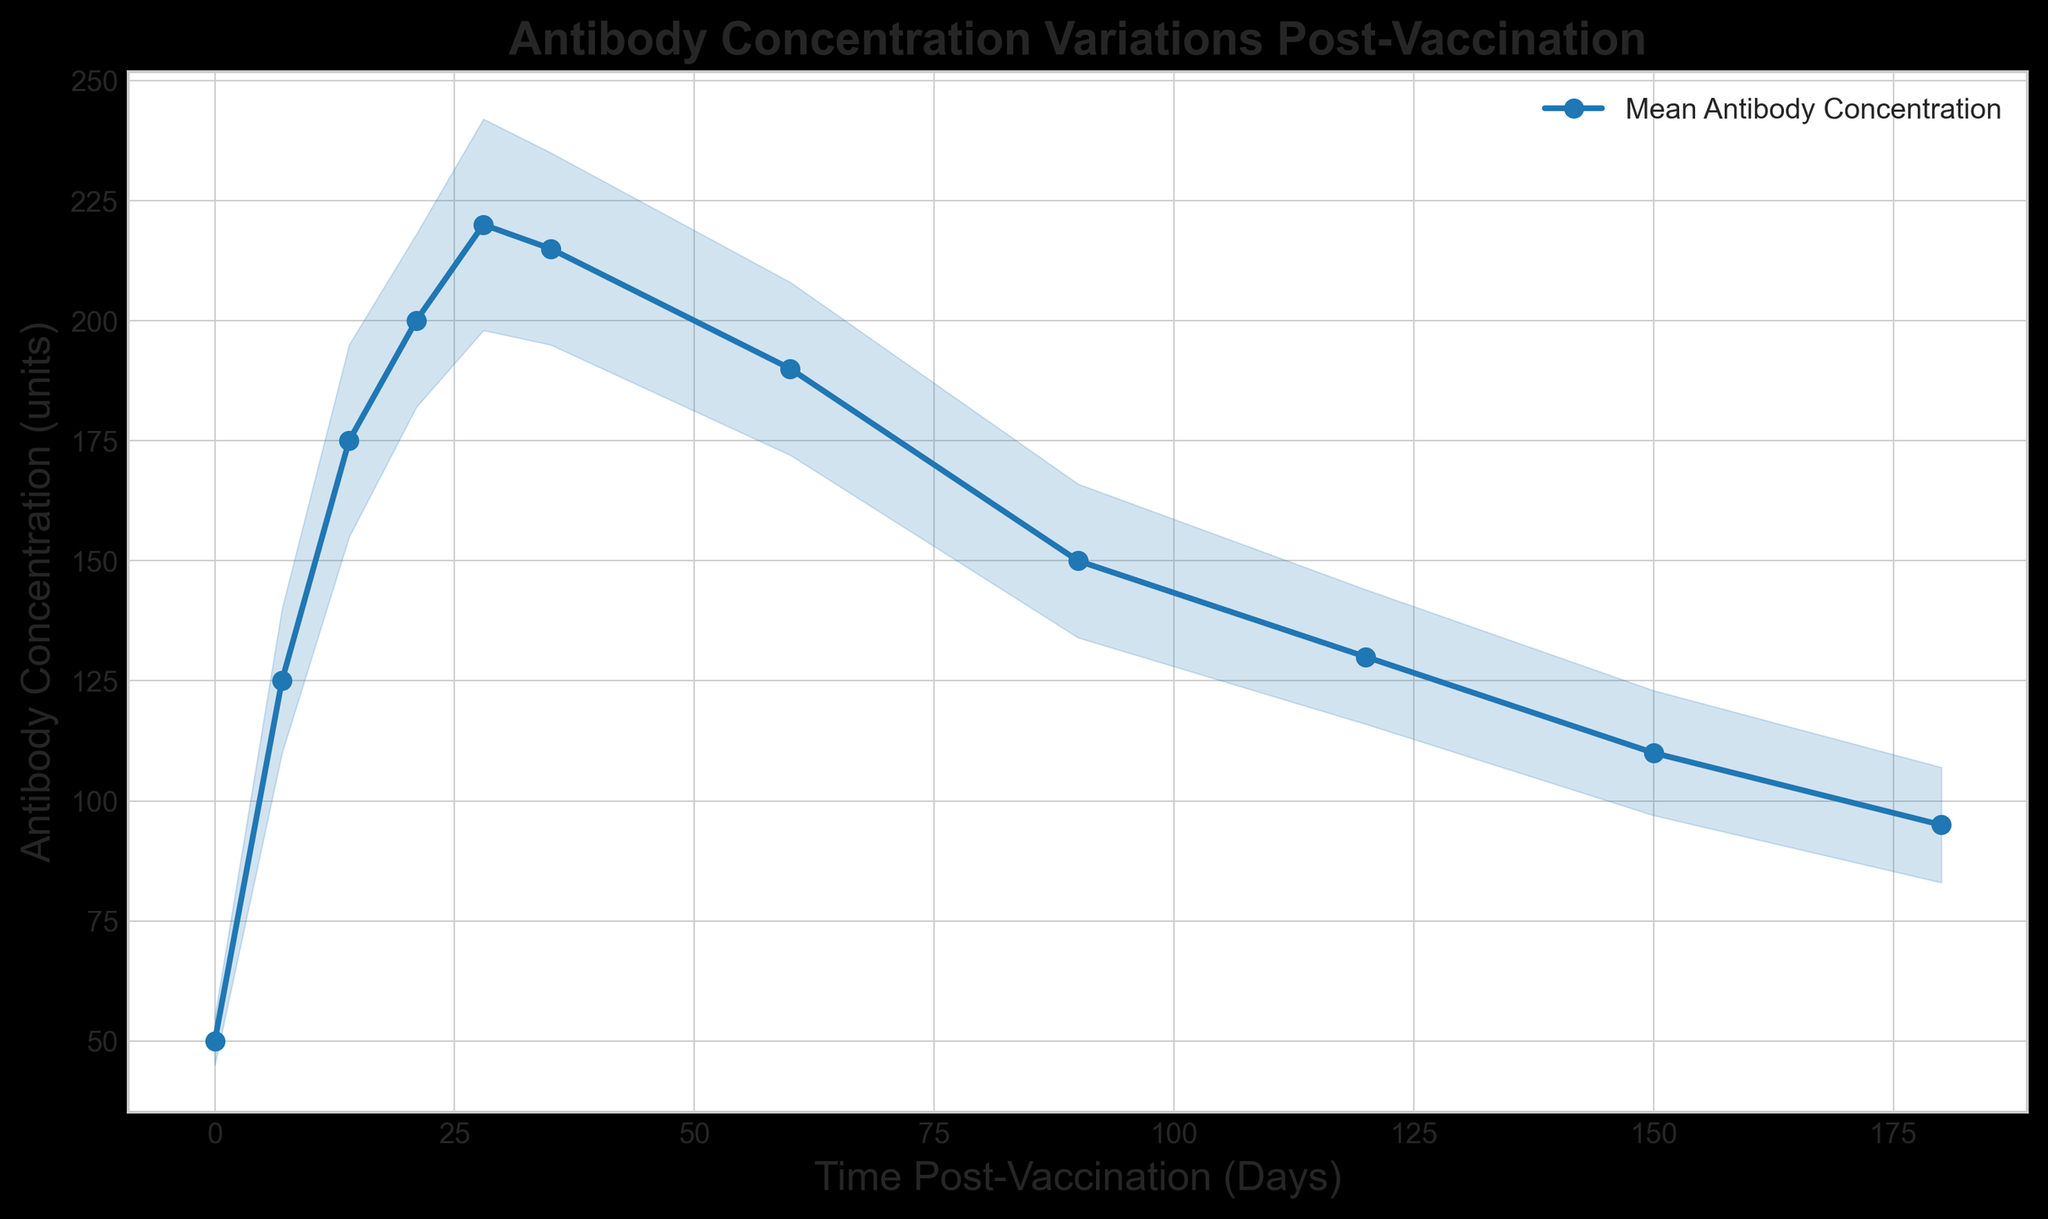What is the highest recorded mean antibody concentration, and on which day does it occur? The highest mean antibody concentration can be determined by looking at the peak of the plotted line. The peak occurs at the time point around 28 days with a concentration of 220 units.
Answer: 220 units on day 28 What is the lowest recorded mean antibody concentration measured after day 7? The lowest mean antibody concentration after day 7 is observed at the end of the six-month period, which is 95 units on day 180.
Answer: 95 units on day 180 What is the total range of antibody concentration values (difference between maximum and minimum mean concentrations) across the time points? The range can be calculated by subtracting the minimum mean value (50 units at day 0) from the maximum mean value (220 units at day 28), giving a range of 170 units.
Answer: 170 units During which period does the antibody concentration decrease most rapidly? By examining the slope of the line, the most rapid decrease can be seen between days 60 and 90, where the line is steepest.
Answer: Between days 60 and 90 Compare the antibody concentrations at days 90 and 150. Which one is higher, and by how much? The mean antibody concentration at day 90 is 150 units, and at day 150, it is 110 units. The difference (higher value at day 90) is 150 - 110 = 40 units.
Answer: Day 90 is higher by 40 units Which time point has the highest standard deviation, indicating the most variability in the antibody concentration? The highest standard deviation can be seen at day 28, where the standard deviation is 22 units.
Answer: Day 28 At what time points do the upper and lower bounds have the largest gap? How large is the gap? The largest gap between the upper and lower bounds occurs at day 28, calculated as (220 + 22) - (220 - 22) = 44 units.
Answer: Day 28, gap of 44 units Is the antibody concentration higher at day 14 or day 35? By comparing the mean values, the antibody concentration is higher on day 14 (175 units) than on day 35 (215 units).
Answer: Day 35 What is the average mean antibody concentration over the entire six-month period? To find the average mean antibody concentration, sum all the mean concentrations and divide by the number of time points: (50 + 125 + 175 + 200 + 220 + 215 + 190 + 150 + 130 + 110 + 95) / 11 ≈ 169.09 units.
Answer: ≈ 169.09 units Between which consecutive time points is the increase in antibody concentration the greatest? By observing the changes between consecutive time points, the greatest increase is from day 0 (50 units) to day 7 (125 units), giving an increase of 75 units.
Answer: Day 0 to day 7 (75 units) 